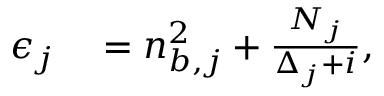<formula> <loc_0><loc_0><loc_500><loc_500>\begin{array} { r l } { \epsilon _ { j } } & = n _ { b , j } ^ { 2 } + \frac { N _ { j } } { \Delta _ { j } + i } , } \end{array}</formula> 